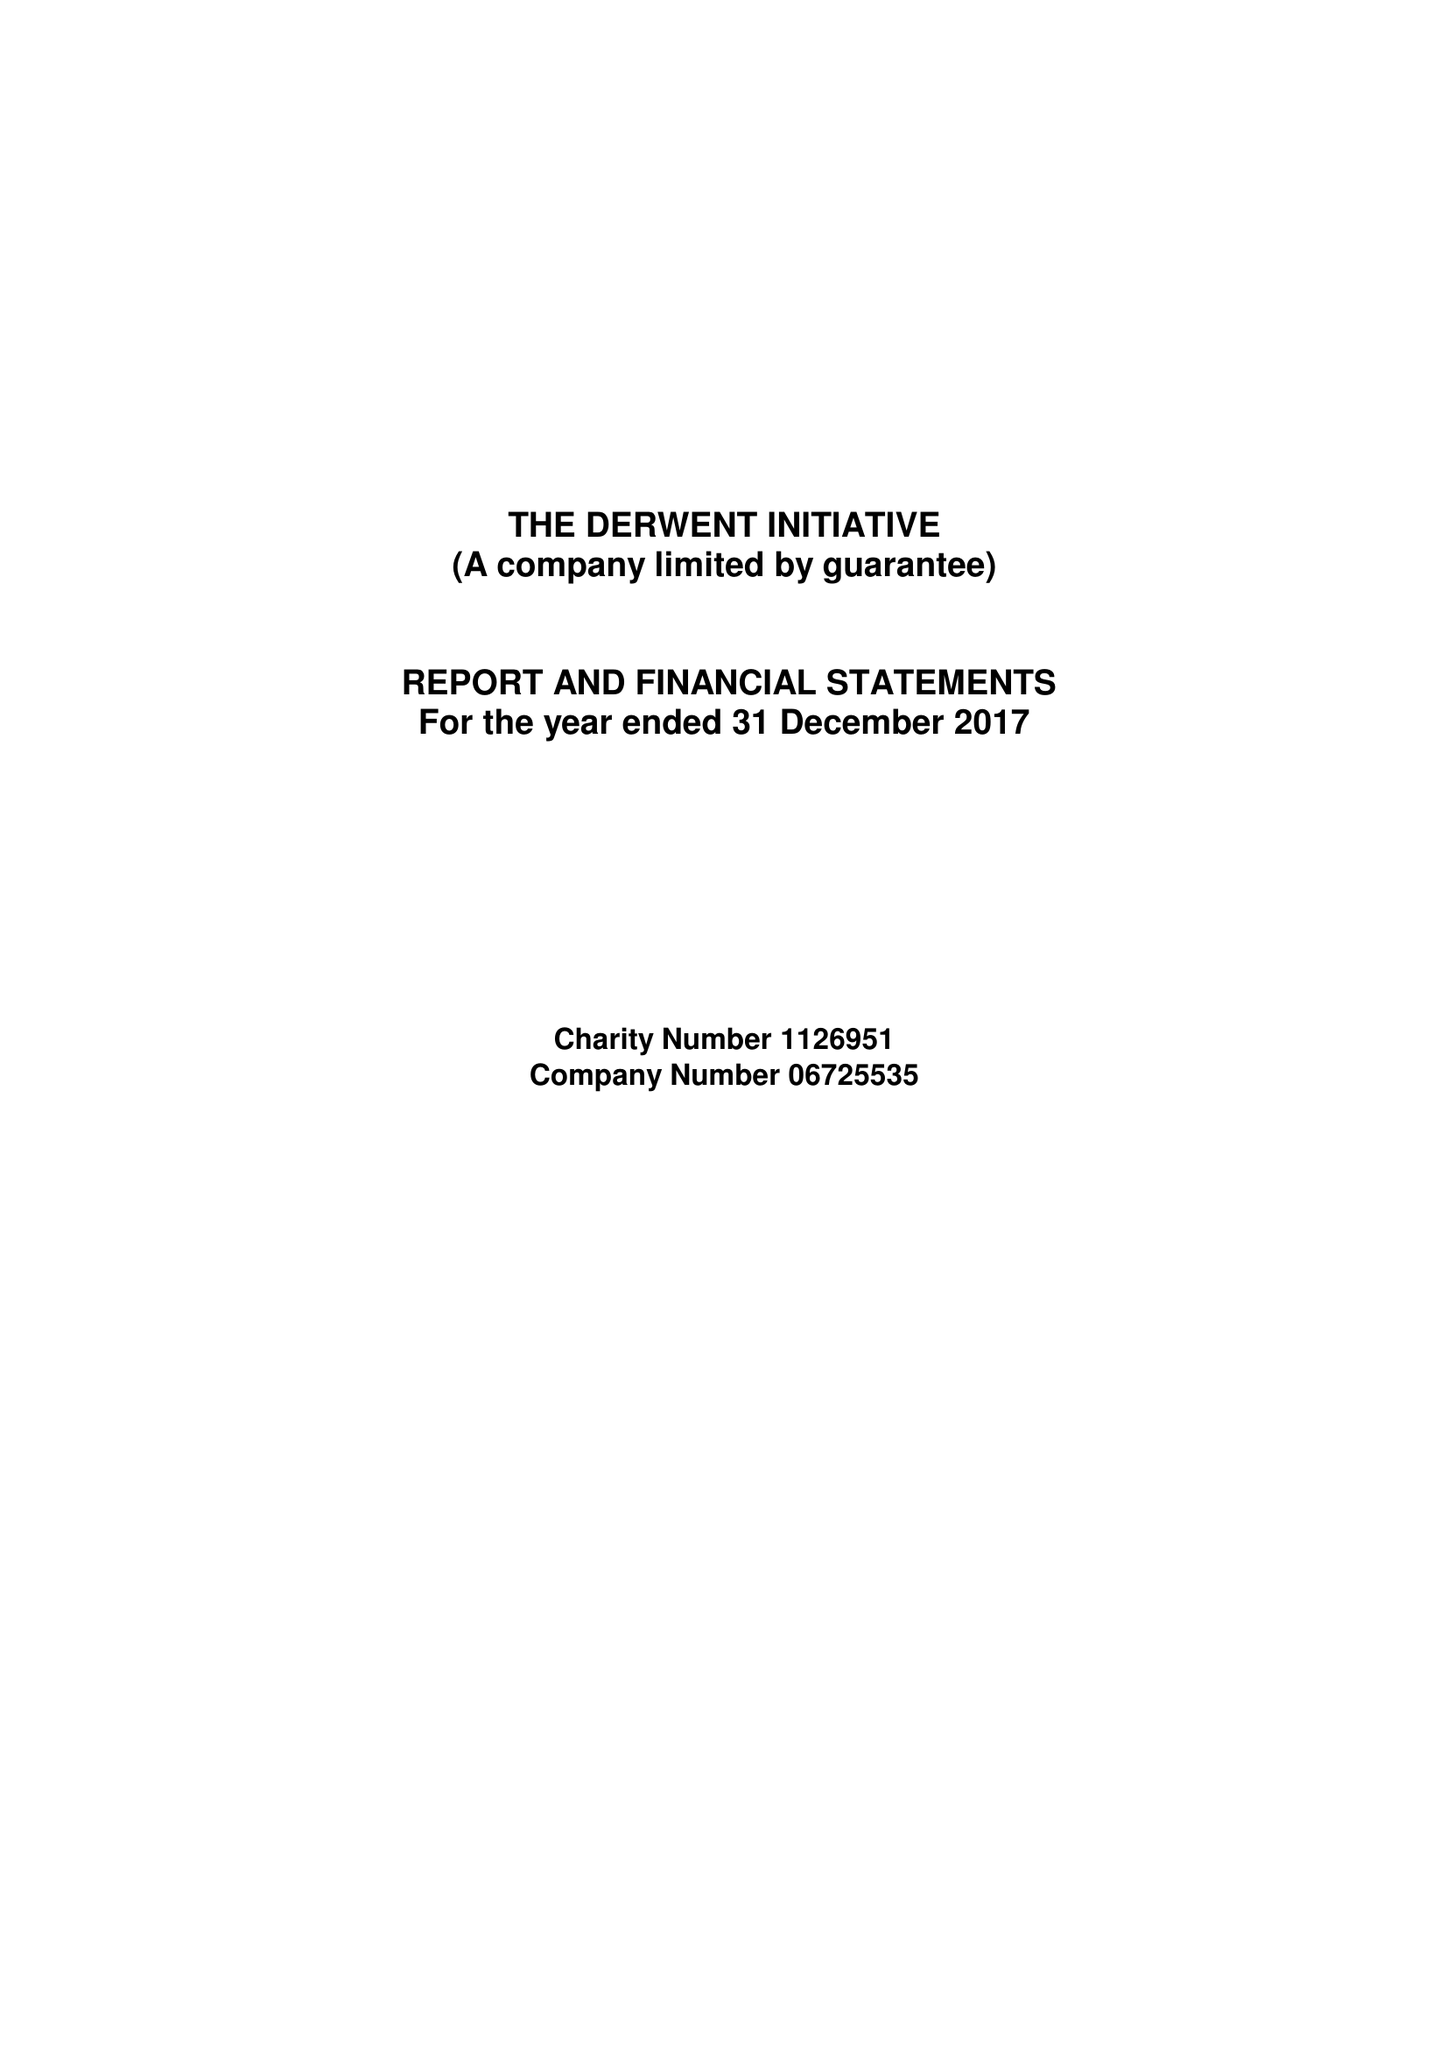What is the value for the spending_annually_in_british_pounds?
Answer the question using a single word or phrase. 99247.00 